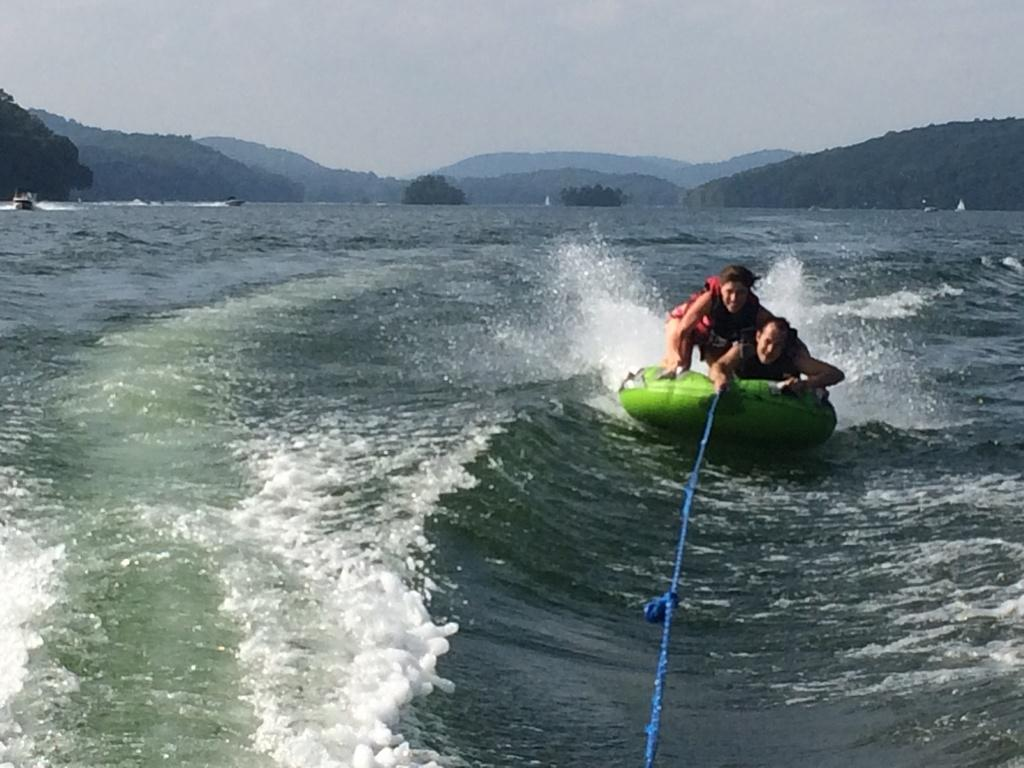How many people are in the image? There are two persons in the image. What are the persons doing in the image? The persons are tubing in the ocean. What can be seen in the background of the image? There are hills and trees in the background of the image. What is visible above the persons and the background? The sky is visible in the image. What type of pan is being used by the persons in the image? There is no pan present in the image; the persons are tubing in the ocean. Can you see a chessboard in the image? There is no chessboard present in the image. 